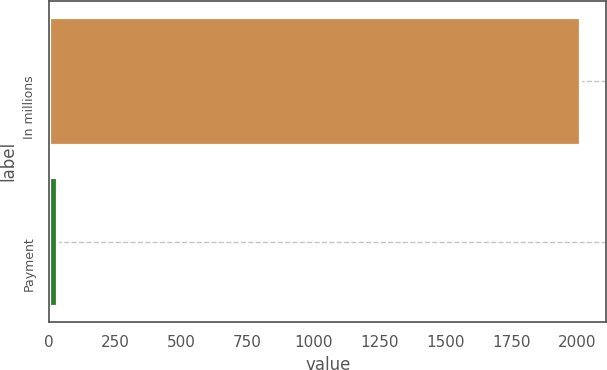<chart> <loc_0><loc_0><loc_500><loc_500><bar_chart><fcel>In millions<fcel>Payment<nl><fcel>2010<fcel>30<nl></chart> 